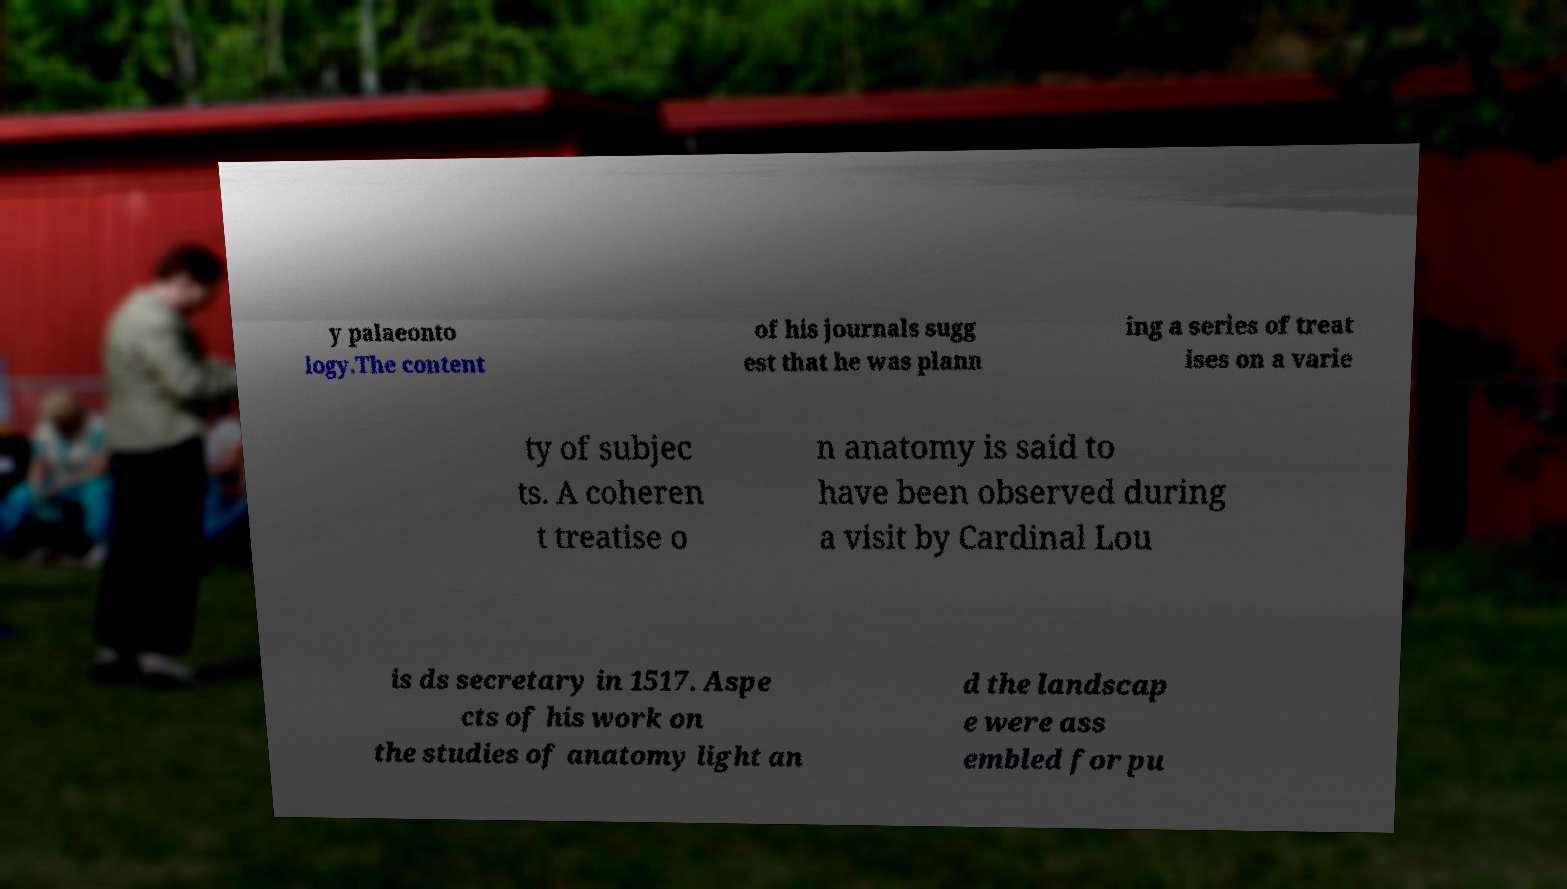I need the written content from this picture converted into text. Can you do that? y palaeonto logy.The content of his journals sugg est that he was plann ing a series of treat ises on a varie ty of subjec ts. A coheren t treatise o n anatomy is said to have been observed during a visit by Cardinal Lou is ds secretary in 1517. Aspe cts of his work on the studies of anatomy light an d the landscap e were ass embled for pu 